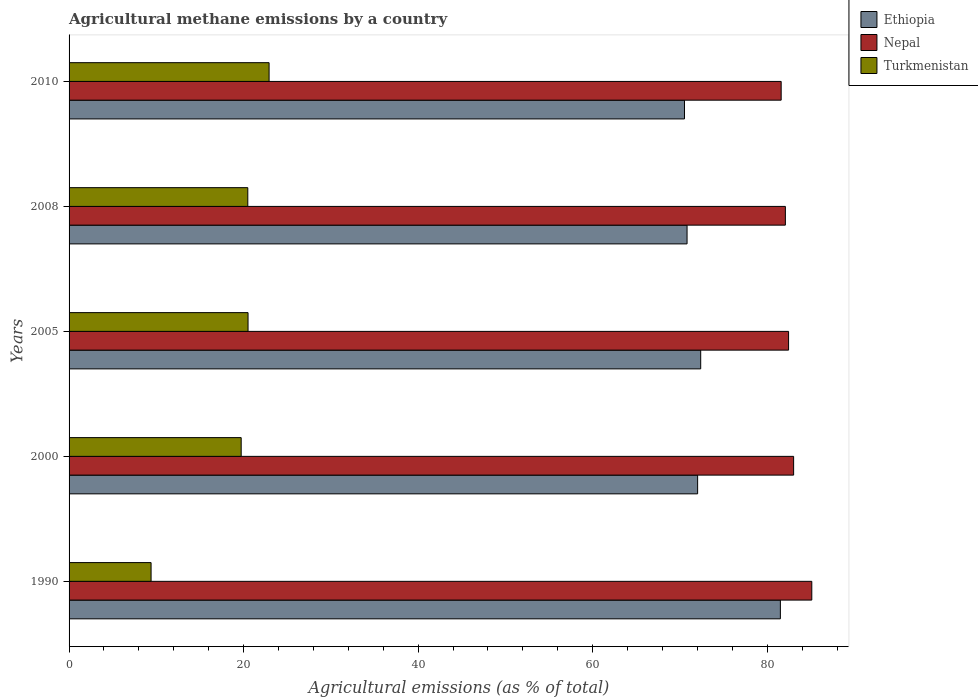Are the number of bars on each tick of the Y-axis equal?
Your answer should be very brief. Yes. What is the label of the 2nd group of bars from the top?
Keep it short and to the point. 2008. In how many cases, is the number of bars for a given year not equal to the number of legend labels?
Provide a succinct answer. 0. What is the amount of agricultural methane emitted in Ethiopia in 2005?
Ensure brevity in your answer.  72.38. Across all years, what is the maximum amount of agricultural methane emitted in Nepal?
Offer a very short reply. 85.1. Across all years, what is the minimum amount of agricultural methane emitted in Nepal?
Your answer should be compact. 81.6. In which year was the amount of agricultural methane emitted in Turkmenistan maximum?
Offer a very short reply. 2010. What is the total amount of agricultural methane emitted in Ethiopia in the graph?
Provide a short and direct response. 367.23. What is the difference between the amount of agricultural methane emitted in Nepal in 1990 and that in 2008?
Offer a terse response. 3.03. What is the difference between the amount of agricultural methane emitted in Turkmenistan in 2000 and the amount of agricultural methane emitted in Nepal in 2008?
Give a very brief answer. -62.36. What is the average amount of agricultural methane emitted in Ethiopia per year?
Offer a terse response. 73.45. In the year 2000, what is the difference between the amount of agricultural methane emitted in Nepal and amount of agricultural methane emitted in Ethiopia?
Your response must be concise. 11. What is the ratio of the amount of agricultural methane emitted in Nepal in 2005 to that in 2008?
Make the answer very short. 1. Is the difference between the amount of agricultural methane emitted in Nepal in 2005 and 2010 greater than the difference between the amount of agricultural methane emitted in Ethiopia in 2005 and 2010?
Your answer should be compact. No. What is the difference between the highest and the second highest amount of agricultural methane emitted in Ethiopia?
Provide a succinct answer. 9.13. What is the difference between the highest and the lowest amount of agricultural methane emitted in Ethiopia?
Offer a very short reply. 10.99. In how many years, is the amount of agricultural methane emitted in Nepal greater than the average amount of agricultural methane emitted in Nepal taken over all years?
Provide a short and direct response. 2. What does the 2nd bar from the top in 2005 represents?
Give a very brief answer. Nepal. What does the 3rd bar from the bottom in 2005 represents?
Your response must be concise. Turkmenistan. Are all the bars in the graph horizontal?
Offer a very short reply. Yes. How many years are there in the graph?
Make the answer very short. 5. Does the graph contain any zero values?
Keep it short and to the point. No. Does the graph contain grids?
Offer a terse response. No. Where does the legend appear in the graph?
Offer a terse response. Top right. How are the legend labels stacked?
Ensure brevity in your answer.  Vertical. What is the title of the graph?
Your response must be concise. Agricultural methane emissions by a country. Does "High income: OECD" appear as one of the legend labels in the graph?
Keep it short and to the point. No. What is the label or title of the X-axis?
Offer a terse response. Agricultural emissions (as % of total). What is the label or title of the Y-axis?
Give a very brief answer. Years. What is the Agricultural emissions (as % of total) of Ethiopia in 1990?
Provide a short and direct response. 81.5. What is the Agricultural emissions (as % of total) in Nepal in 1990?
Offer a terse response. 85.1. What is the Agricultural emissions (as % of total) of Turkmenistan in 1990?
Offer a terse response. 9.4. What is the Agricultural emissions (as % of total) of Ethiopia in 2000?
Ensure brevity in your answer.  72.02. What is the Agricultural emissions (as % of total) of Nepal in 2000?
Offer a terse response. 83.02. What is the Agricultural emissions (as % of total) of Turkmenistan in 2000?
Offer a very short reply. 19.72. What is the Agricultural emissions (as % of total) in Ethiopia in 2005?
Ensure brevity in your answer.  72.38. What is the Agricultural emissions (as % of total) of Nepal in 2005?
Ensure brevity in your answer.  82.45. What is the Agricultural emissions (as % of total) in Turkmenistan in 2005?
Offer a very short reply. 20.51. What is the Agricultural emissions (as % of total) of Ethiopia in 2008?
Your answer should be very brief. 70.81. What is the Agricultural emissions (as % of total) in Nepal in 2008?
Make the answer very short. 82.08. What is the Agricultural emissions (as % of total) of Turkmenistan in 2008?
Your answer should be very brief. 20.48. What is the Agricultural emissions (as % of total) in Ethiopia in 2010?
Give a very brief answer. 70.52. What is the Agricultural emissions (as % of total) of Nepal in 2010?
Provide a succinct answer. 81.6. What is the Agricultural emissions (as % of total) in Turkmenistan in 2010?
Offer a terse response. 22.92. Across all years, what is the maximum Agricultural emissions (as % of total) of Ethiopia?
Offer a terse response. 81.5. Across all years, what is the maximum Agricultural emissions (as % of total) in Nepal?
Your answer should be compact. 85.1. Across all years, what is the maximum Agricultural emissions (as % of total) in Turkmenistan?
Give a very brief answer. 22.92. Across all years, what is the minimum Agricultural emissions (as % of total) of Ethiopia?
Offer a very short reply. 70.52. Across all years, what is the minimum Agricultural emissions (as % of total) of Nepal?
Provide a short and direct response. 81.6. Across all years, what is the minimum Agricultural emissions (as % of total) of Turkmenistan?
Offer a terse response. 9.4. What is the total Agricultural emissions (as % of total) in Ethiopia in the graph?
Make the answer very short. 367.23. What is the total Agricultural emissions (as % of total) of Nepal in the graph?
Provide a short and direct response. 414.25. What is the total Agricultural emissions (as % of total) in Turkmenistan in the graph?
Keep it short and to the point. 93.02. What is the difference between the Agricultural emissions (as % of total) in Ethiopia in 1990 and that in 2000?
Ensure brevity in your answer.  9.48. What is the difference between the Agricultural emissions (as % of total) in Nepal in 1990 and that in 2000?
Your answer should be very brief. 2.08. What is the difference between the Agricultural emissions (as % of total) of Turkmenistan in 1990 and that in 2000?
Your answer should be very brief. -10.32. What is the difference between the Agricultural emissions (as % of total) in Ethiopia in 1990 and that in 2005?
Your answer should be very brief. 9.13. What is the difference between the Agricultural emissions (as % of total) in Nepal in 1990 and that in 2005?
Ensure brevity in your answer.  2.66. What is the difference between the Agricultural emissions (as % of total) in Turkmenistan in 1990 and that in 2005?
Keep it short and to the point. -11.11. What is the difference between the Agricultural emissions (as % of total) in Ethiopia in 1990 and that in 2008?
Keep it short and to the point. 10.69. What is the difference between the Agricultural emissions (as % of total) of Nepal in 1990 and that in 2008?
Your answer should be very brief. 3.03. What is the difference between the Agricultural emissions (as % of total) of Turkmenistan in 1990 and that in 2008?
Provide a succinct answer. -11.08. What is the difference between the Agricultural emissions (as % of total) of Ethiopia in 1990 and that in 2010?
Make the answer very short. 10.99. What is the difference between the Agricultural emissions (as % of total) in Nepal in 1990 and that in 2010?
Your answer should be compact. 3.51. What is the difference between the Agricultural emissions (as % of total) of Turkmenistan in 1990 and that in 2010?
Your answer should be compact. -13.52. What is the difference between the Agricultural emissions (as % of total) in Ethiopia in 2000 and that in 2005?
Your answer should be very brief. -0.35. What is the difference between the Agricultural emissions (as % of total) in Nepal in 2000 and that in 2005?
Keep it short and to the point. 0.58. What is the difference between the Agricultural emissions (as % of total) of Turkmenistan in 2000 and that in 2005?
Your answer should be very brief. -0.79. What is the difference between the Agricultural emissions (as % of total) in Ethiopia in 2000 and that in 2008?
Your answer should be compact. 1.21. What is the difference between the Agricultural emissions (as % of total) in Nepal in 2000 and that in 2008?
Make the answer very short. 0.95. What is the difference between the Agricultural emissions (as % of total) in Turkmenistan in 2000 and that in 2008?
Offer a very short reply. -0.76. What is the difference between the Agricultural emissions (as % of total) in Ethiopia in 2000 and that in 2010?
Provide a short and direct response. 1.51. What is the difference between the Agricultural emissions (as % of total) of Nepal in 2000 and that in 2010?
Your answer should be compact. 1.43. What is the difference between the Agricultural emissions (as % of total) in Turkmenistan in 2000 and that in 2010?
Offer a terse response. -3.2. What is the difference between the Agricultural emissions (as % of total) in Ethiopia in 2005 and that in 2008?
Provide a succinct answer. 1.56. What is the difference between the Agricultural emissions (as % of total) of Nepal in 2005 and that in 2008?
Your response must be concise. 0.37. What is the difference between the Agricultural emissions (as % of total) in Turkmenistan in 2005 and that in 2008?
Offer a very short reply. 0.03. What is the difference between the Agricultural emissions (as % of total) in Ethiopia in 2005 and that in 2010?
Offer a terse response. 1.86. What is the difference between the Agricultural emissions (as % of total) of Nepal in 2005 and that in 2010?
Give a very brief answer. 0.85. What is the difference between the Agricultural emissions (as % of total) in Turkmenistan in 2005 and that in 2010?
Offer a very short reply. -2.41. What is the difference between the Agricultural emissions (as % of total) in Ethiopia in 2008 and that in 2010?
Your response must be concise. 0.29. What is the difference between the Agricultural emissions (as % of total) in Nepal in 2008 and that in 2010?
Provide a short and direct response. 0.48. What is the difference between the Agricultural emissions (as % of total) of Turkmenistan in 2008 and that in 2010?
Your answer should be very brief. -2.44. What is the difference between the Agricultural emissions (as % of total) of Ethiopia in 1990 and the Agricultural emissions (as % of total) of Nepal in 2000?
Keep it short and to the point. -1.52. What is the difference between the Agricultural emissions (as % of total) in Ethiopia in 1990 and the Agricultural emissions (as % of total) in Turkmenistan in 2000?
Give a very brief answer. 61.78. What is the difference between the Agricultural emissions (as % of total) of Nepal in 1990 and the Agricultural emissions (as % of total) of Turkmenistan in 2000?
Your response must be concise. 65.38. What is the difference between the Agricultural emissions (as % of total) of Ethiopia in 1990 and the Agricultural emissions (as % of total) of Nepal in 2005?
Your answer should be very brief. -0.94. What is the difference between the Agricultural emissions (as % of total) in Ethiopia in 1990 and the Agricultural emissions (as % of total) in Turkmenistan in 2005?
Make the answer very short. 61. What is the difference between the Agricultural emissions (as % of total) of Nepal in 1990 and the Agricultural emissions (as % of total) of Turkmenistan in 2005?
Your answer should be compact. 64.6. What is the difference between the Agricultural emissions (as % of total) of Ethiopia in 1990 and the Agricultural emissions (as % of total) of Nepal in 2008?
Give a very brief answer. -0.57. What is the difference between the Agricultural emissions (as % of total) of Ethiopia in 1990 and the Agricultural emissions (as % of total) of Turkmenistan in 2008?
Provide a short and direct response. 61.03. What is the difference between the Agricultural emissions (as % of total) in Nepal in 1990 and the Agricultural emissions (as % of total) in Turkmenistan in 2008?
Give a very brief answer. 64.63. What is the difference between the Agricultural emissions (as % of total) in Ethiopia in 1990 and the Agricultural emissions (as % of total) in Nepal in 2010?
Ensure brevity in your answer.  -0.09. What is the difference between the Agricultural emissions (as % of total) in Ethiopia in 1990 and the Agricultural emissions (as % of total) in Turkmenistan in 2010?
Keep it short and to the point. 58.59. What is the difference between the Agricultural emissions (as % of total) in Nepal in 1990 and the Agricultural emissions (as % of total) in Turkmenistan in 2010?
Ensure brevity in your answer.  62.19. What is the difference between the Agricultural emissions (as % of total) in Ethiopia in 2000 and the Agricultural emissions (as % of total) in Nepal in 2005?
Ensure brevity in your answer.  -10.42. What is the difference between the Agricultural emissions (as % of total) of Ethiopia in 2000 and the Agricultural emissions (as % of total) of Turkmenistan in 2005?
Give a very brief answer. 51.52. What is the difference between the Agricultural emissions (as % of total) of Nepal in 2000 and the Agricultural emissions (as % of total) of Turkmenistan in 2005?
Your response must be concise. 62.52. What is the difference between the Agricultural emissions (as % of total) in Ethiopia in 2000 and the Agricultural emissions (as % of total) in Nepal in 2008?
Offer a terse response. -10.05. What is the difference between the Agricultural emissions (as % of total) in Ethiopia in 2000 and the Agricultural emissions (as % of total) in Turkmenistan in 2008?
Your answer should be compact. 51.54. What is the difference between the Agricultural emissions (as % of total) in Nepal in 2000 and the Agricultural emissions (as % of total) in Turkmenistan in 2008?
Keep it short and to the point. 62.54. What is the difference between the Agricultural emissions (as % of total) in Ethiopia in 2000 and the Agricultural emissions (as % of total) in Nepal in 2010?
Your answer should be compact. -9.57. What is the difference between the Agricultural emissions (as % of total) in Ethiopia in 2000 and the Agricultural emissions (as % of total) in Turkmenistan in 2010?
Keep it short and to the point. 49.1. What is the difference between the Agricultural emissions (as % of total) of Nepal in 2000 and the Agricultural emissions (as % of total) of Turkmenistan in 2010?
Offer a terse response. 60.1. What is the difference between the Agricultural emissions (as % of total) in Ethiopia in 2005 and the Agricultural emissions (as % of total) in Nepal in 2008?
Provide a succinct answer. -9.7. What is the difference between the Agricultural emissions (as % of total) of Ethiopia in 2005 and the Agricultural emissions (as % of total) of Turkmenistan in 2008?
Keep it short and to the point. 51.9. What is the difference between the Agricultural emissions (as % of total) in Nepal in 2005 and the Agricultural emissions (as % of total) in Turkmenistan in 2008?
Keep it short and to the point. 61.97. What is the difference between the Agricultural emissions (as % of total) of Ethiopia in 2005 and the Agricultural emissions (as % of total) of Nepal in 2010?
Make the answer very short. -9.22. What is the difference between the Agricultural emissions (as % of total) in Ethiopia in 2005 and the Agricultural emissions (as % of total) in Turkmenistan in 2010?
Offer a terse response. 49.46. What is the difference between the Agricultural emissions (as % of total) of Nepal in 2005 and the Agricultural emissions (as % of total) of Turkmenistan in 2010?
Make the answer very short. 59.53. What is the difference between the Agricultural emissions (as % of total) of Ethiopia in 2008 and the Agricultural emissions (as % of total) of Nepal in 2010?
Offer a terse response. -10.78. What is the difference between the Agricultural emissions (as % of total) in Ethiopia in 2008 and the Agricultural emissions (as % of total) in Turkmenistan in 2010?
Ensure brevity in your answer.  47.89. What is the difference between the Agricultural emissions (as % of total) of Nepal in 2008 and the Agricultural emissions (as % of total) of Turkmenistan in 2010?
Give a very brief answer. 59.16. What is the average Agricultural emissions (as % of total) in Ethiopia per year?
Make the answer very short. 73.45. What is the average Agricultural emissions (as % of total) in Nepal per year?
Keep it short and to the point. 82.85. What is the average Agricultural emissions (as % of total) in Turkmenistan per year?
Offer a terse response. 18.6. In the year 1990, what is the difference between the Agricultural emissions (as % of total) of Ethiopia and Agricultural emissions (as % of total) of Nepal?
Give a very brief answer. -3.6. In the year 1990, what is the difference between the Agricultural emissions (as % of total) in Ethiopia and Agricultural emissions (as % of total) in Turkmenistan?
Offer a terse response. 72.11. In the year 1990, what is the difference between the Agricultural emissions (as % of total) in Nepal and Agricultural emissions (as % of total) in Turkmenistan?
Provide a short and direct response. 75.71. In the year 2000, what is the difference between the Agricultural emissions (as % of total) of Ethiopia and Agricultural emissions (as % of total) of Nepal?
Offer a very short reply. -11. In the year 2000, what is the difference between the Agricultural emissions (as % of total) of Ethiopia and Agricultural emissions (as % of total) of Turkmenistan?
Offer a terse response. 52.3. In the year 2000, what is the difference between the Agricultural emissions (as % of total) of Nepal and Agricultural emissions (as % of total) of Turkmenistan?
Keep it short and to the point. 63.3. In the year 2005, what is the difference between the Agricultural emissions (as % of total) in Ethiopia and Agricultural emissions (as % of total) in Nepal?
Ensure brevity in your answer.  -10.07. In the year 2005, what is the difference between the Agricultural emissions (as % of total) of Ethiopia and Agricultural emissions (as % of total) of Turkmenistan?
Give a very brief answer. 51.87. In the year 2005, what is the difference between the Agricultural emissions (as % of total) in Nepal and Agricultural emissions (as % of total) in Turkmenistan?
Provide a short and direct response. 61.94. In the year 2008, what is the difference between the Agricultural emissions (as % of total) of Ethiopia and Agricultural emissions (as % of total) of Nepal?
Your answer should be compact. -11.27. In the year 2008, what is the difference between the Agricultural emissions (as % of total) in Ethiopia and Agricultural emissions (as % of total) in Turkmenistan?
Keep it short and to the point. 50.33. In the year 2008, what is the difference between the Agricultural emissions (as % of total) of Nepal and Agricultural emissions (as % of total) of Turkmenistan?
Ensure brevity in your answer.  61.6. In the year 2010, what is the difference between the Agricultural emissions (as % of total) of Ethiopia and Agricultural emissions (as % of total) of Nepal?
Your response must be concise. -11.08. In the year 2010, what is the difference between the Agricultural emissions (as % of total) of Ethiopia and Agricultural emissions (as % of total) of Turkmenistan?
Offer a terse response. 47.6. In the year 2010, what is the difference between the Agricultural emissions (as % of total) in Nepal and Agricultural emissions (as % of total) in Turkmenistan?
Give a very brief answer. 58.68. What is the ratio of the Agricultural emissions (as % of total) of Ethiopia in 1990 to that in 2000?
Ensure brevity in your answer.  1.13. What is the ratio of the Agricultural emissions (as % of total) in Nepal in 1990 to that in 2000?
Make the answer very short. 1.03. What is the ratio of the Agricultural emissions (as % of total) in Turkmenistan in 1990 to that in 2000?
Provide a succinct answer. 0.48. What is the ratio of the Agricultural emissions (as % of total) of Ethiopia in 1990 to that in 2005?
Provide a short and direct response. 1.13. What is the ratio of the Agricultural emissions (as % of total) in Nepal in 1990 to that in 2005?
Offer a terse response. 1.03. What is the ratio of the Agricultural emissions (as % of total) in Turkmenistan in 1990 to that in 2005?
Give a very brief answer. 0.46. What is the ratio of the Agricultural emissions (as % of total) in Ethiopia in 1990 to that in 2008?
Ensure brevity in your answer.  1.15. What is the ratio of the Agricultural emissions (as % of total) in Nepal in 1990 to that in 2008?
Offer a terse response. 1.04. What is the ratio of the Agricultural emissions (as % of total) of Turkmenistan in 1990 to that in 2008?
Offer a very short reply. 0.46. What is the ratio of the Agricultural emissions (as % of total) of Ethiopia in 1990 to that in 2010?
Your answer should be compact. 1.16. What is the ratio of the Agricultural emissions (as % of total) of Nepal in 1990 to that in 2010?
Ensure brevity in your answer.  1.04. What is the ratio of the Agricultural emissions (as % of total) of Turkmenistan in 1990 to that in 2010?
Ensure brevity in your answer.  0.41. What is the ratio of the Agricultural emissions (as % of total) of Nepal in 2000 to that in 2005?
Your answer should be very brief. 1.01. What is the ratio of the Agricultural emissions (as % of total) of Turkmenistan in 2000 to that in 2005?
Make the answer very short. 0.96. What is the ratio of the Agricultural emissions (as % of total) of Ethiopia in 2000 to that in 2008?
Make the answer very short. 1.02. What is the ratio of the Agricultural emissions (as % of total) in Nepal in 2000 to that in 2008?
Offer a terse response. 1.01. What is the ratio of the Agricultural emissions (as % of total) in Ethiopia in 2000 to that in 2010?
Provide a short and direct response. 1.02. What is the ratio of the Agricultural emissions (as % of total) of Nepal in 2000 to that in 2010?
Offer a very short reply. 1.02. What is the ratio of the Agricultural emissions (as % of total) of Turkmenistan in 2000 to that in 2010?
Ensure brevity in your answer.  0.86. What is the ratio of the Agricultural emissions (as % of total) in Ethiopia in 2005 to that in 2008?
Your answer should be very brief. 1.02. What is the ratio of the Agricultural emissions (as % of total) of Turkmenistan in 2005 to that in 2008?
Keep it short and to the point. 1. What is the ratio of the Agricultural emissions (as % of total) of Ethiopia in 2005 to that in 2010?
Offer a terse response. 1.03. What is the ratio of the Agricultural emissions (as % of total) of Nepal in 2005 to that in 2010?
Your answer should be compact. 1.01. What is the ratio of the Agricultural emissions (as % of total) in Turkmenistan in 2005 to that in 2010?
Provide a succinct answer. 0.89. What is the ratio of the Agricultural emissions (as % of total) of Nepal in 2008 to that in 2010?
Offer a terse response. 1.01. What is the ratio of the Agricultural emissions (as % of total) of Turkmenistan in 2008 to that in 2010?
Provide a short and direct response. 0.89. What is the difference between the highest and the second highest Agricultural emissions (as % of total) of Ethiopia?
Provide a short and direct response. 9.13. What is the difference between the highest and the second highest Agricultural emissions (as % of total) of Nepal?
Your answer should be very brief. 2.08. What is the difference between the highest and the second highest Agricultural emissions (as % of total) of Turkmenistan?
Provide a short and direct response. 2.41. What is the difference between the highest and the lowest Agricultural emissions (as % of total) in Ethiopia?
Keep it short and to the point. 10.99. What is the difference between the highest and the lowest Agricultural emissions (as % of total) in Nepal?
Provide a succinct answer. 3.51. What is the difference between the highest and the lowest Agricultural emissions (as % of total) in Turkmenistan?
Ensure brevity in your answer.  13.52. 